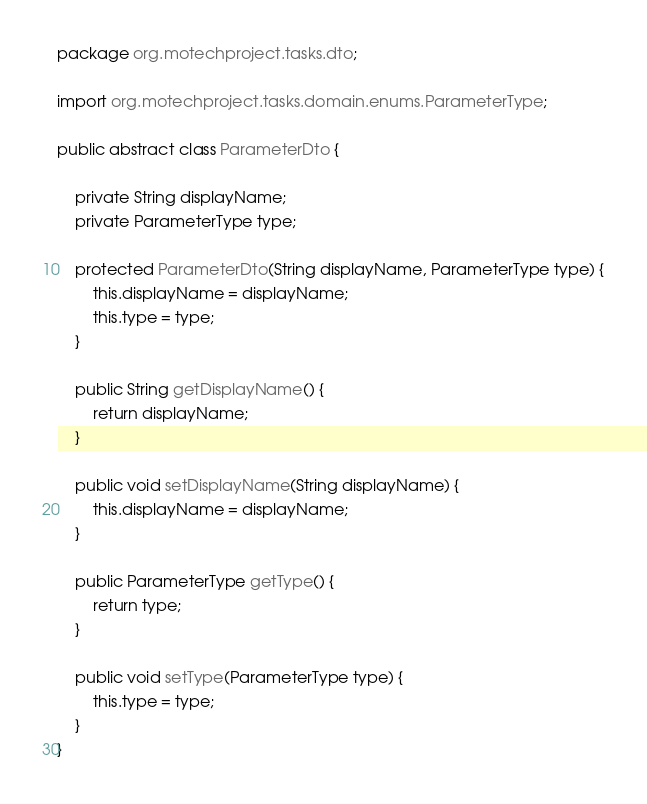<code> <loc_0><loc_0><loc_500><loc_500><_Java_>package org.motechproject.tasks.dto;

import org.motechproject.tasks.domain.enums.ParameterType;

public abstract class ParameterDto {

    private String displayName;
    private ParameterType type;

    protected ParameterDto(String displayName, ParameterType type) {
        this.displayName = displayName;
        this.type = type;
    }

    public String getDisplayName() {
        return displayName;
    }

    public void setDisplayName(String displayName) {
        this.displayName = displayName;
    }

    public ParameterType getType() {
        return type;
    }

    public void setType(ParameterType type) {
        this.type = type;
    }
}
</code> 